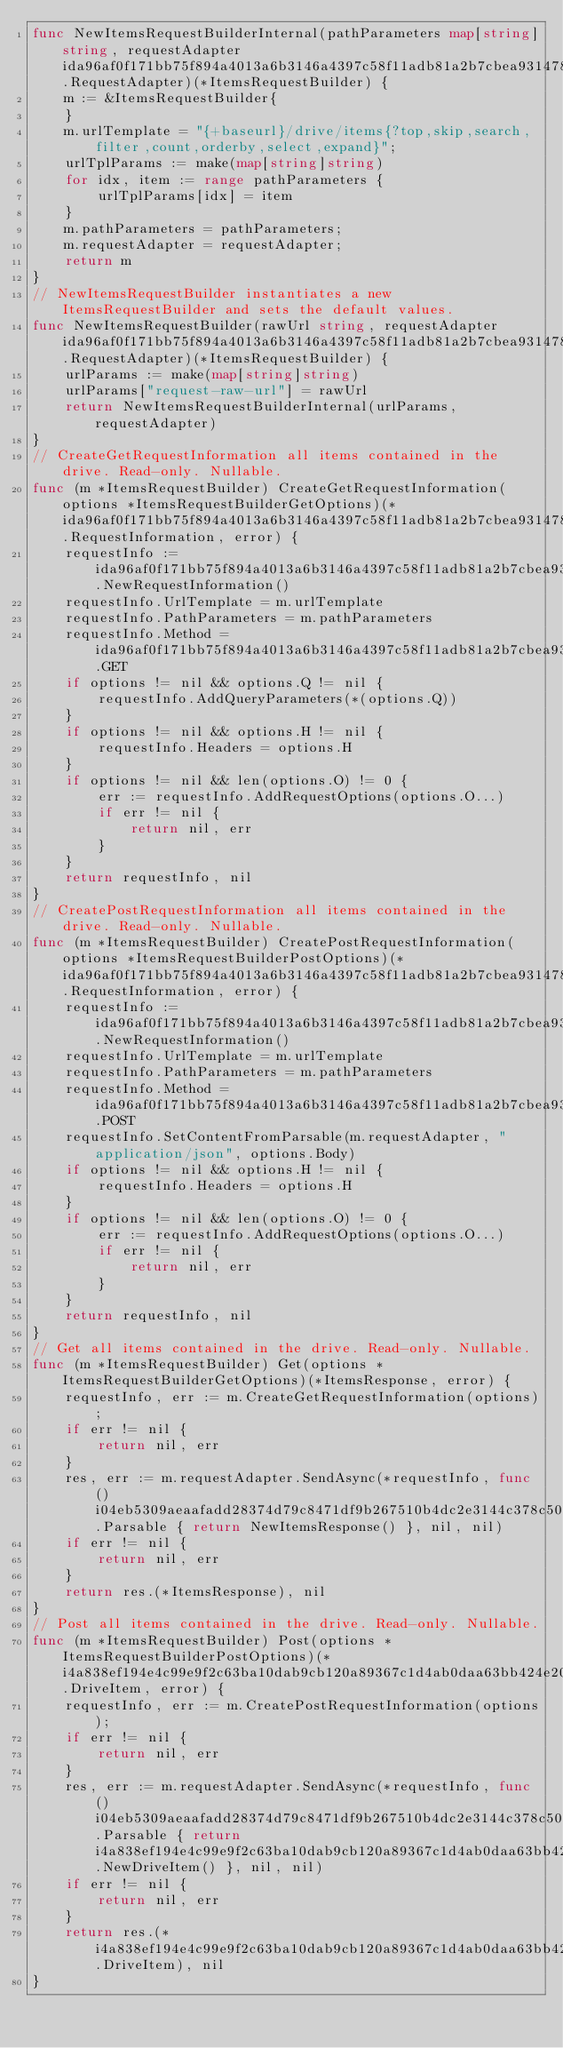Convert code to text. <code><loc_0><loc_0><loc_500><loc_500><_Go_>func NewItemsRequestBuilderInternal(pathParameters map[string]string, requestAdapter ida96af0f171bb75f894a4013a6b3146a4397c58f11adb81a2b7cbea9314783a9.RequestAdapter)(*ItemsRequestBuilder) {
    m := &ItemsRequestBuilder{
    }
    m.urlTemplate = "{+baseurl}/drive/items{?top,skip,search,filter,count,orderby,select,expand}";
    urlTplParams := make(map[string]string)
    for idx, item := range pathParameters {
        urlTplParams[idx] = item
    }
    m.pathParameters = pathParameters;
    m.requestAdapter = requestAdapter;
    return m
}
// NewItemsRequestBuilder instantiates a new ItemsRequestBuilder and sets the default values.
func NewItemsRequestBuilder(rawUrl string, requestAdapter ida96af0f171bb75f894a4013a6b3146a4397c58f11adb81a2b7cbea9314783a9.RequestAdapter)(*ItemsRequestBuilder) {
    urlParams := make(map[string]string)
    urlParams["request-raw-url"] = rawUrl
    return NewItemsRequestBuilderInternal(urlParams, requestAdapter)
}
// CreateGetRequestInformation all items contained in the drive. Read-only. Nullable.
func (m *ItemsRequestBuilder) CreateGetRequestInformation(options *ItemsRequestBuilderGetOptions)(*ida96af0f171bb75f894a4013a6b3146a4397c58f11adb81a2b7cbea9314783a9.RequestInformation, error) {
    requestInfo := ida96af0f171bb75f894a4013a6b3146a4397c58f11adb81a2b7cbea9314783a9.NewRequestInformation()
    requestInfo.UrlTemplate = m.urlTemplate
    requestInfo.PathParameters = m.pathParameters
    requestInfo.Method = ida96af0f171bb75f894a4013a6b3146a4397c58f11adb81a2b7cbea9314783a9.GET
    if options != nil && options.Q != nil {
        requestInfo.AddQueryParameters(*(options.Q))
    }
    if options != nil && options.H != nil {
        requestInfo.Headers = options.H
    }
    if options != nil && len(options.O) != 0 {
        err := requestInfo.AddRequestOptions(options.O...)
        if err != nil {
            return nil, err
        }
    }
    return requestInfo, nil
}
// CreatePostRequestInformation all items contained in the drive. Read-only. Nullable.
func (m *ItemsRequestBuilder) CreatePostRequestInformation(options *ItemsRequestBuilderPostOptions)(*ida96af0f171bb75f894a4013a6b3146a4397c58f11adb81a2b7cbea9314783a9.RequestInformation, error) {
    requestInfo := ida96af0f171bb75f894a4013a6b3146a4397c58f11adb81a2b7cbea9314783a9.NewRequestInformation()
    requestInfo.UrlTemplate = m.urlTemplate
    requestInfo.PathParameters = m.pathParameters
    requestInfo.Method = ida96af0f171bb75f894a4013a6b3146a4397c58f11adb81a2b7cbea9314783a9.POST
    requestInfo.SetContentFromParsable(m.requestAdapter, "application/json", options.Body)
    if options != nil && options.H != nil {
        requestInfo.Headers = options.H
    }
    if options != nil && len(options.O) != 0 {
        err := requestInfo.AddRequestOptions(options.O...)
        if err != nil {
            return nil, err
        }
    }
    return requestInfo, nil
}
// Get all items contained in the drive. Read-only. Nullable.
func (m *ItemsRequestBuilder) Get(options *ItemsRequestBuilderGetOptions)(*ItemsResponse, error) {
    requestInfo, err := m.CreateGetRequestInformation(options);
    if err != nil {
        return nil, err
    }
    res, err := m.requestAdapter.SendAsync(*requestInfo, func () i04eb5309aeaafadd28374d79c8471df9b267510b4dc2e3144c378c50f6fd7b55.Parsable { return NewItemsResponse() }, nil, nil)
    if err != nil {
        return nil, err
    }
    return res.(*ItemsResponse), nil
}
// Post all items contained in the drive. Read-only. Nullable.
func (m *ItemsRequestBuilder) Post(options *ItemsRequestBuilderPostOptions)(*i4a838ef194e4c99e9f2c63ba10dab9cb120a89367c1d4ab0daa63bb424e20d87.DriveItem, error) {
    requestInfo, err := m.CreatePostRequestInformation(options);
    if err != nil {
        return nil, err
    }
    res, err := m.requestAdapter.SendAsync(*requestInfo, func () i04eb5309aeaafadd28374d79c8471df9b267510b4dc2e3144c378c50f6fd7b55.Parsable { return i4a838ef194e4c99e9f2c63ba10dab9cb120a89367c1d4ab0daa63bb424e20d87.NewDriveItem() }, nil, nil)
    if err != nil {
        return nil, err
    }
    return res.(*i4a838ef194e4c99e9f2c63ba10dab9cb120a89367c1d4ab0daa63bb424e20d87.DriveItem), nil
}
</code> 